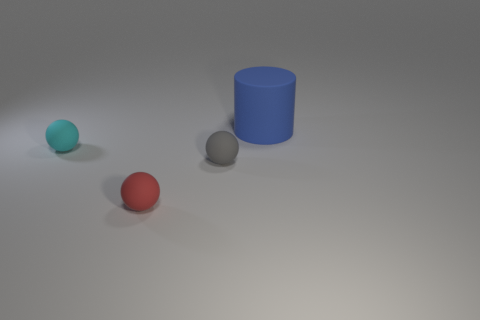Can you describe the shapes and colors of the objects in the image? Certainly, there are three objects in the image. Starting from the left, there is a small teal sphere, in the middle is a small red sphere, and on the right is a larger blue cylindrical object. 